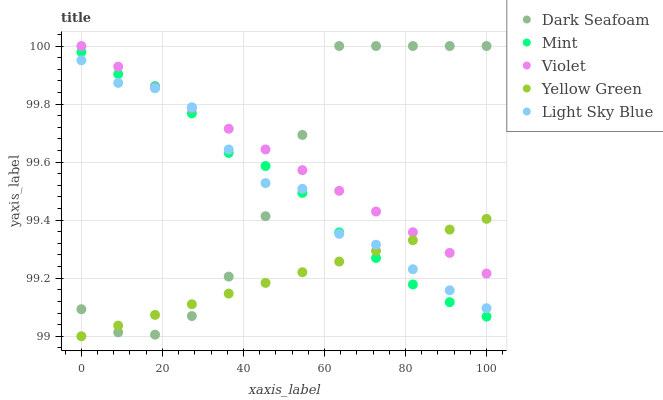Does Yellow Green have the minimum area under the curve?
Answer yes or no. Yes. Does Violet have the maximum area under the curve?
Answer yes or no. Yes. Does Light Sky Blue have the minimum area under the curve?
Answer yes or no. No. Does Light Sky Blue have the maximum area under the curve?
Answer yes or no. No. Is Violet the smoothest?
Answer yes or no. Yes. Is Dark Seafoam the roughest?
Answer yes or no. Yes. Is Light Sky Blue the smoothest?
Answer yes or no. No. Is Light Sky Blue the roughest?
Answer yes or no. No. Does Yellow Green have the lowest value?
Answer yes or no. Yes. Does Light Sky Blue have the lowest value?
Answer yes or no. No. Does Violet have the highest value?
Answer yes or no. Yes. Does Light Sky Blue have the highest value?
Answer yes or no. No. Does Light Sky Blue intersect Yellow Green?
Answer yes or no. Yes. Is Light Sky Blue less than Yellow Green?
Answer yes or no. No. Is Light Sky Blue greater than Yellow Green?
Answer yes or no. No. 